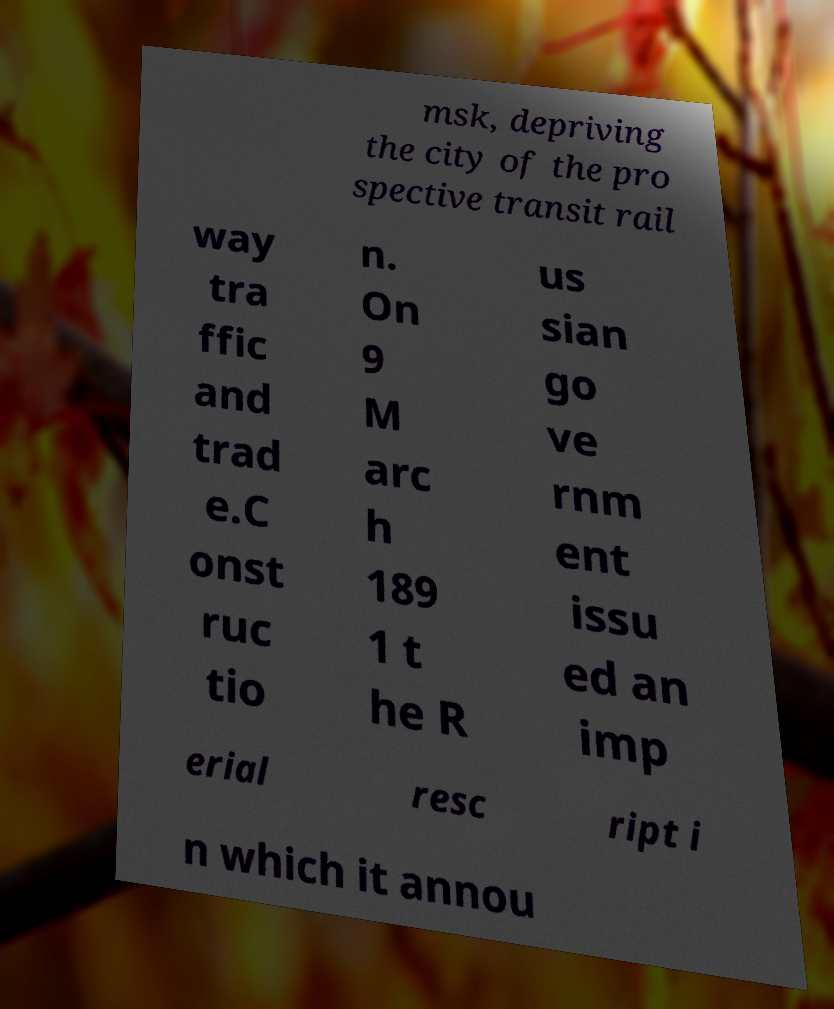I need the written content from this picture converted into text. Can you do that? msk, depriving the city of the pro spective transit rail way tra ffic and trad e.C onst ruc tio n. On 9 M arc h 189 1 t he R us sian go ve rnm ent issu ed an imp erial resc ript i n which it annou 